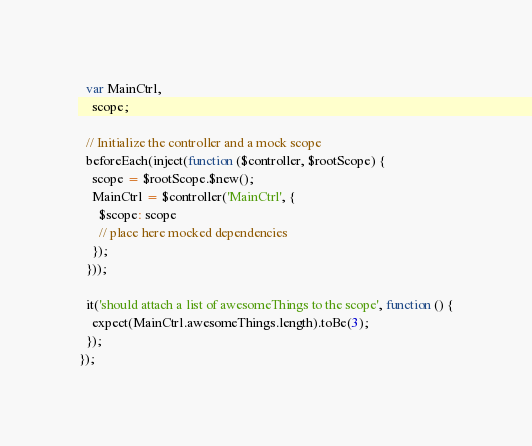<code> <loc_0><loc_0><loc_500><loc_500><_JavaScript_>  var MainCtrl,
    scope;

  // Initialize the controller and a mock scope
  beforeEach(inject(function ($controller, $rootScope) {
    scope = $rootScope.$new();
    MainCtrl = $controller('MainCtrl', {
      $scope: scope
      // place here mocked dependencies
    });
  }));

  it('should attach a list of awesomeThings to the scope', function () {
    expect(MainCtrl.awesomeThings.length).toBe(3);
  });
});
</code> 